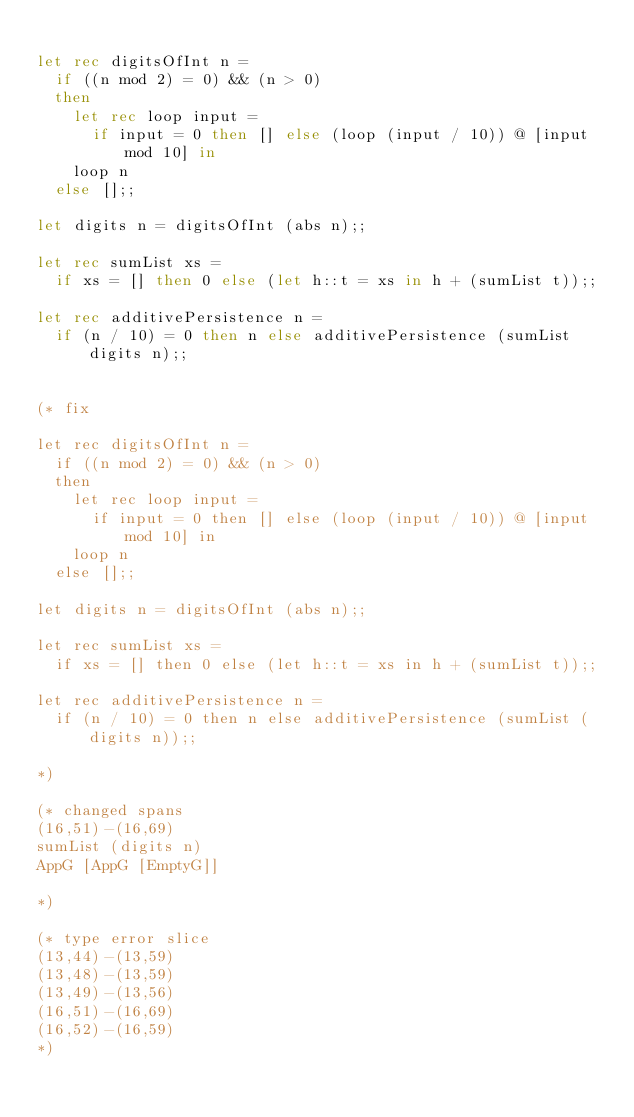Convert code to text. <code><loc_0><loc_0><loc_500><loc_500><_OCaml_>
let rec digitsOfInt n =
  if ((n mod 2) = 0) && (n > 0)
  then
    let rec loop input =
      if input = 0 then [] else (loop (input / 10)) @ [input mod 10] in
    loop n
  else [];;

let digits n = digitsOfInt (abs n);;

let rec sumList xs =
  if xs = [] then 0 else (let h::t = xs in h + (sumList t));;

let rec additivePersistence n =
  if (n / 10) = 0 then n else additivePersistence (sumList digits n);;


(* fix

let rec digitsOfInt n =
  if ((n mod 2) = 0) && (n > 0)
  then
    let rec loop input =
      if input = 0 then [] else (loop (input / 10)) @ [input mod 10] in
    loop n
  else [];;

let digits n = digitsOfInt (abs n);;

let rec sumList xs =
  if xs = [] then 0 else (let h::t = xs in h + (sumList t));;

let rec additivePersistence n =
  if (n / 10) = 0 then n else additivePersistence (sumList (digits n));;

*)

(* changed spans
(16,51)-(16,69)
sumList (digits n)
AppG [AppG [EmptyG]]

*)

(* type error slice
(13,44)-(13,59)
(13,48)-(13,59)
(13,49)-(13,56)
(16,51)-(16,69)
(16,52)-(16,59)
*)
</code> 